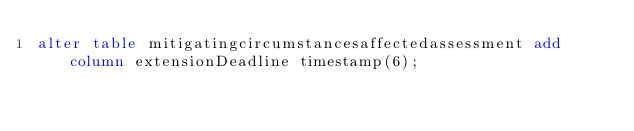Convert code to text. <code><loc_0><loc_0><loc_500><loc_500><_SQL_>alter table mitigatingcircumstancesaffectedassessment add column extensionDeadline timestamp(6);</code> 